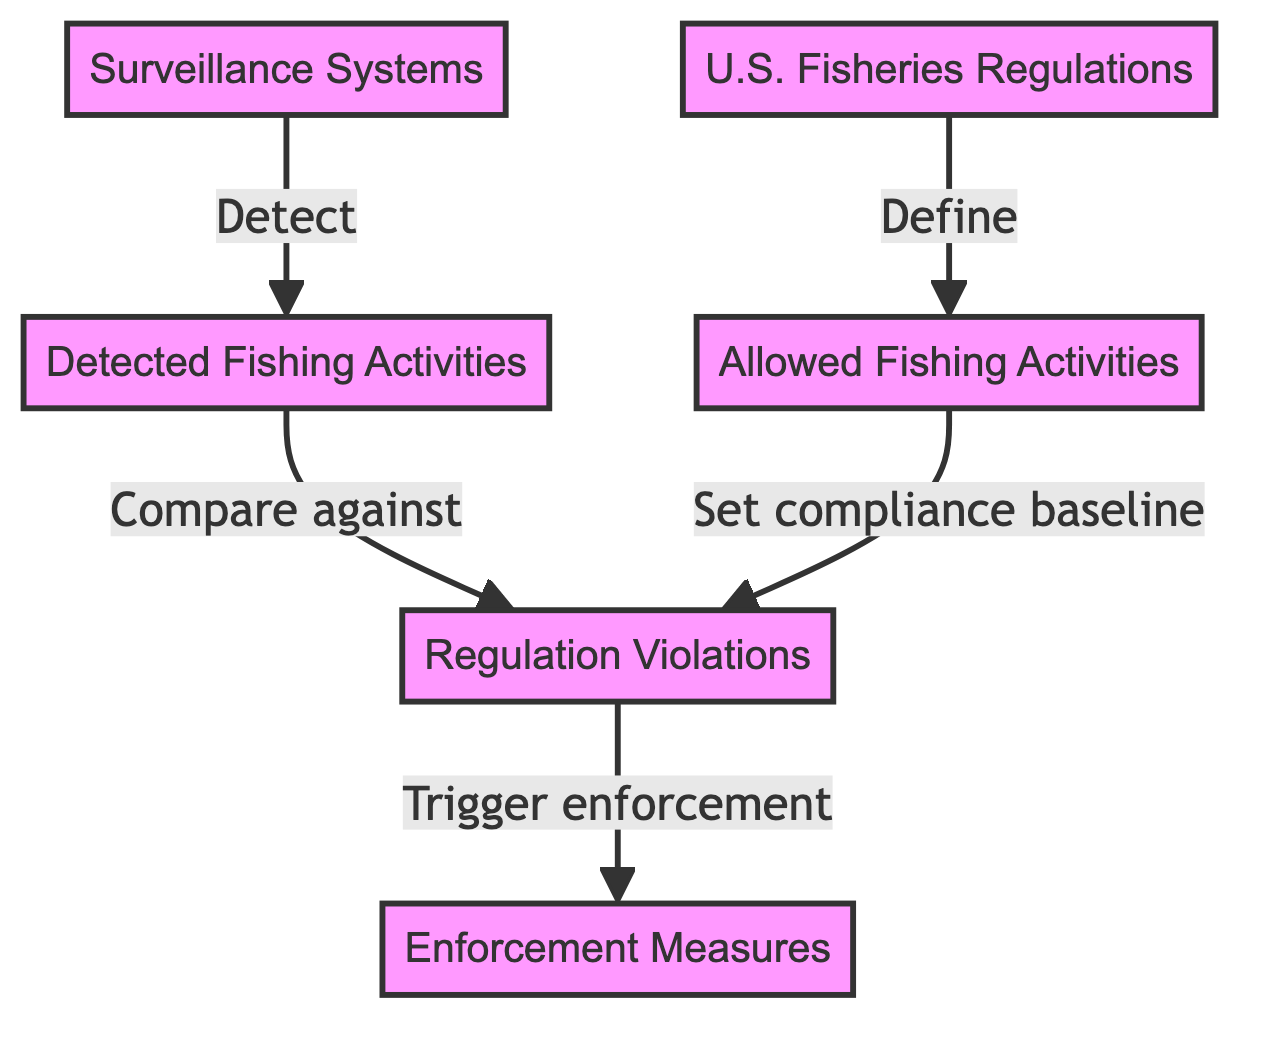What is the main purpose of the regulations node? The regulations node is connected to the allowed fishing activities node, indicating that it defines or establishes what constitutes allowed fishing activities. This relationship highlights the role of regulations in guiding compliance.
Answer: Define How many nodes are present in the diagram? The diagram consists of six distinct nodes: detected fishing, allowed fishing, regulations, violations, enforcement measures, and surveillance systems. This count includes all the unique entities represented in the flowchart.
Answer: Six Which node is responsible for detecting fishing activities? The surveillance systems node has an arrow pointing to the detected fishing activities node, indicating that it is responsible for the detection process related to fishing activities.
Answer: Surveillance Systems What action does a violation trigger? The violation node is linked to the enforcement measures node, which shows that violations trigger corresponding enforcement actions. This relationship suggests a direct consequence focus for regulatory noncompliance.
Answer: Enforcement Measures How are allowed fishing activities defined? The allowed fishing activities node is defined by the regulations node, indicating that the regulations provide the necessary guidelines or criteria for what activities are considered allowed.
Answer: Regulations What purpose does detected fishing activities serve concerning violations? Detected fishing activities are compared against violations to evaluate compliance. This comparison helps in identifying potential infringements and understanding the scope of illegal practices.
Answer: Compare against Which node sets the compliance baseline? The allowed fishing activities node is indicated to set the compliance baseline, which serves as a reference point for evaluating whether detected activities conform to established regulations.
Answer: Allowed Fishing Activities What connects the violations to enforcement measures? The connection from the violations node to the enforcement measures node suggests that any identified violations will lead to enforcement actions being taken to address noncompliance with fishing regulations.
Answer: Trigger enforcement How many edges are in the diagram? The flowchart shows five distinct edges that connect the nodes, each representing the relationships between entities regarding compliance and enforcement in fisheries.
Answer: Five 